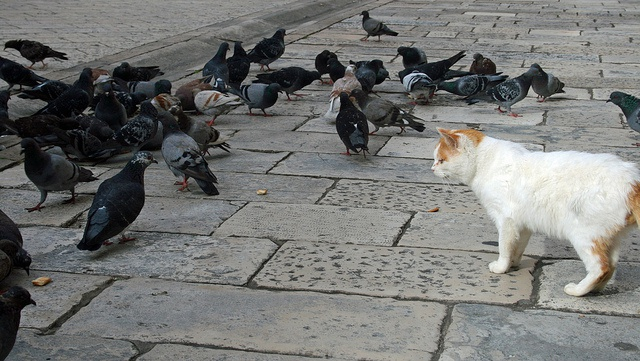Describe the objects in this image and their specific colors. I can see cat in gray, lightgray, and darkgray tones, bird in gray, black, and purple tones, bird in gray, black, darkblue, and blue tones, bird in gray, black, and purple tones, and bird in gray, black, and darkgray tones in this image. 